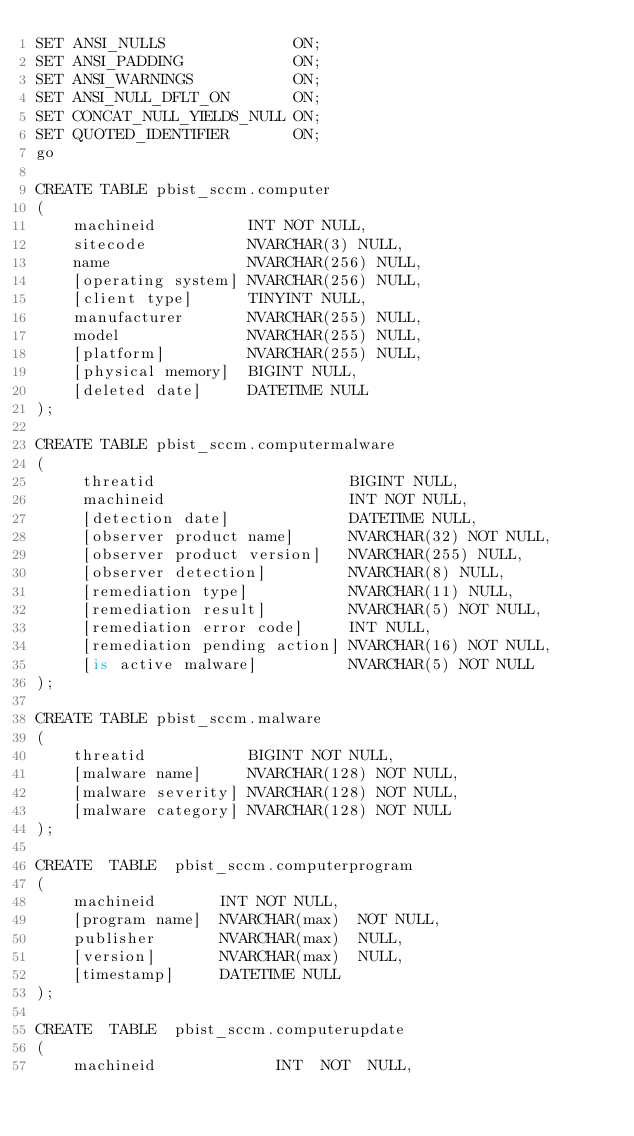<code> <loc_0><loc_0><loc_500><loc_500><_SQL_>SET ANSI_NULLS              ON;
SET ANSI_PADDING            ON;
SET ANSI_WARNINGS           ON;
SET ANSI_NULL_DFLT_ON       ON;
SET CONCAT_NULL_YIELDS_NULL ON;
SET QUOTED_IDENTIFIER       ON;
go

CREATE TABLE pbist_sccm.computer
(
    machineid          INT NOT NULL,
    sitecode           NVARCHAR(3) NULL,
    name               NVARCHAR(256) NULL,
    [operating system] NVARCHAR(256) NULL,
    [client type]      TINYINT NULL,
    manufacturer       NVARCHAR(255) NULL,
    model              NVARCHAR(255) NULL,
    [platform]         NVARCHAR(255) NULL,
    [physical memory]  BIGINT NULL,
    [deleted date]     DATETIME NULL
);

CREATE TABLE pbist_sccm.computermalware
(
     threatid                     BIGINT NULL,
     machineid                    INT NOT NULL,
     [detection date]             DATETIME NULL,
     [observer product name]      NVARCHAR(32) NOT NULL,
     [observer product version]   NVARCHAR(255) NULL,
     [observer detection]         NVARCHAR(8) NULL,
     [remediation type]           NVARCHAR(11) NULL,
     [remediation result]         NVARCHAR(5) NOT NULL,
     [remediation error code]     INT NULL,
     [remediation pending action] NVARCHAR(16) NOT NULL,
     [is active malware]          NVARCHAR(5) NOT NULL
);

CREATE TABLE pbist_sccm.malware
(
    threatid           BIGINT NOT NULL,
    [malware name]     NVARCHAR(128) NOT NULL,
    [malware severity] NVARCHAR(128) NOT NULL,
    [malware category] NVARCHAR(128) NOT NULL
);

CREATE  TABLE  pbist_sccm.computerprogram
(
    machineid       INT NOT NULL,
    [program name]  NVARCHAR(max)  NOT NULL,
    publisher       NVARCHAR(max)  NULL,
    [version]       NVARCHAR(max)  NULL,
    [timestamp]     DATETIME NULL
);

CREATE  TABLE  pbist_sccm.computerupdate
(
    machineid             INT  NOT  NULL,</code> 